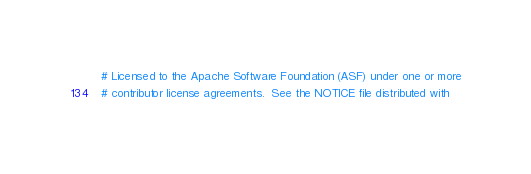<code> <loc_0><loc_0><loc_500><loc_500><_Awk_># Licensed to the Apache Software Foundation (ASF) under one or more
# contributor license agreements.  See the NOTICE file distributed with</code> 